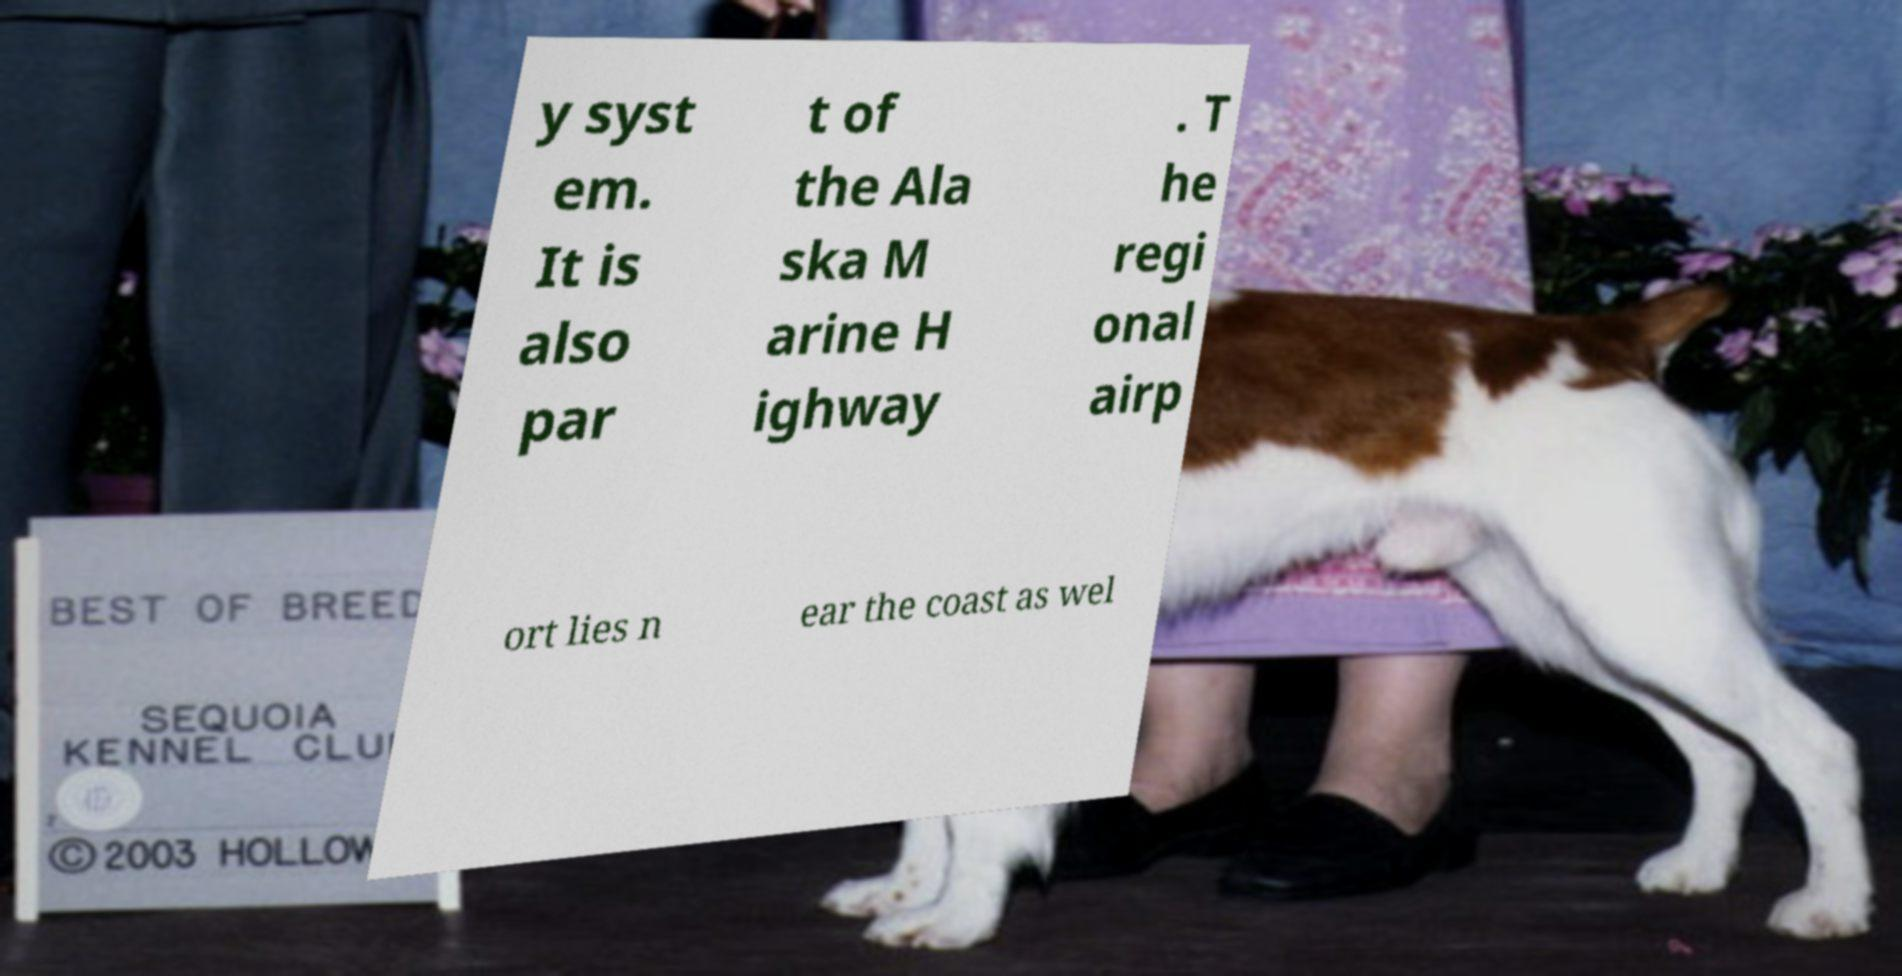Could you assist in decoding the text presented in this image and type it out clearly? y syst em. It is also par t of the Ala ska M arine H ighway . T he regi onal airp ort lies n ear the coast as wel 